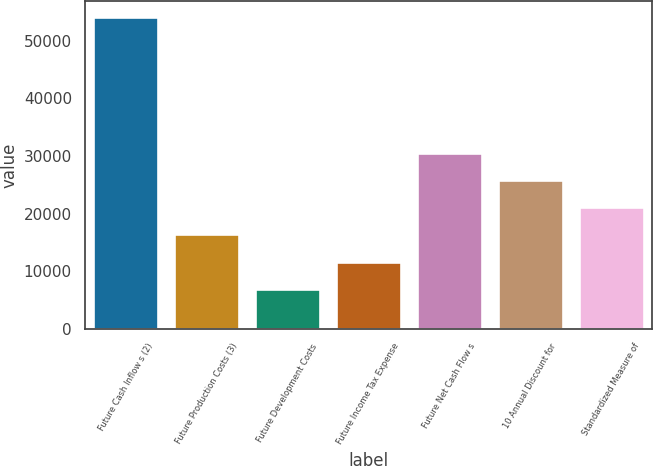<chart> <loc_0><loc_0><loc_500><loc_500><bar_chart><fcel>Future Cash Inflow s (2)<fcel>Future Production Costs (3)<fcel>Future Development Costs<fcel>Future Income Tax Expense<fcel>Future Net Cash Flow s<fcel>10 Annual Discount for<fcel>Standardized Measure of<nl><fcel>54184<fcel>16360.8<fcel>6905<fcel>11632.9<fcel>30544.5<fcel>25816.6<fcel>21088.7<nl></chart> 